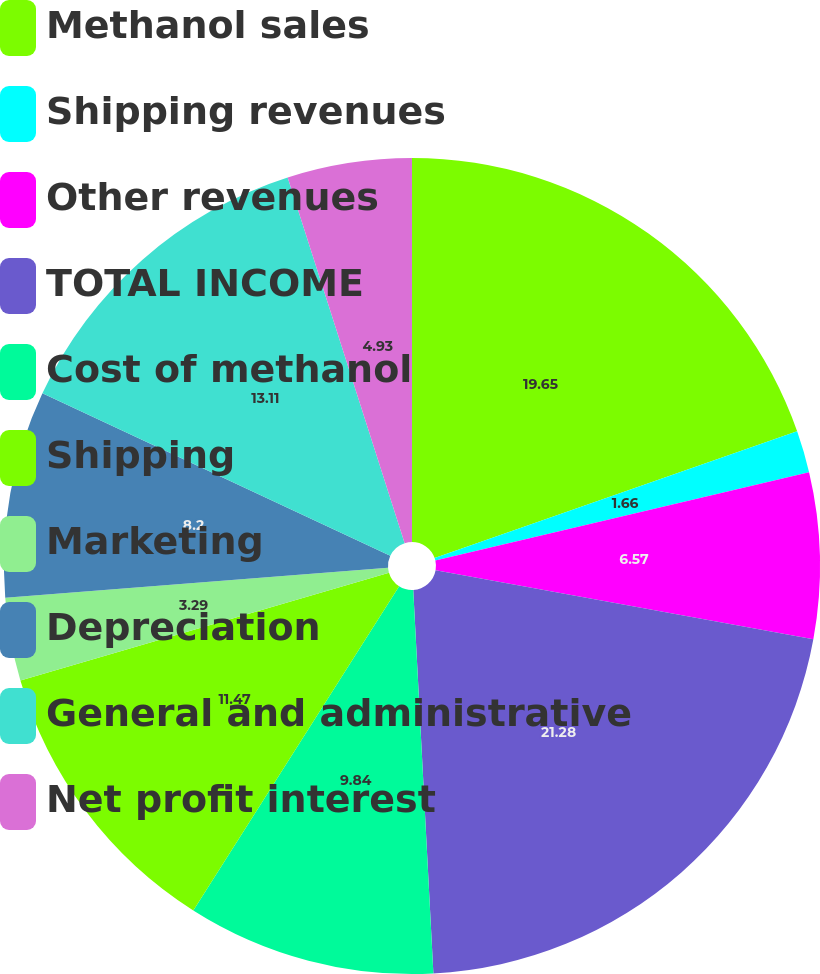<chart> <loc_0><loc_0><loc_500><loc_500><pie_chart><fcel>Methanol sales<fcel>Shipping revenues<fcel>Other revenues<fcel>TOTAL INCOME<fcel>Cost of methanol<fcel>Shipping<fcel>Marketing<fcel>Depreciation<fcel>General and administrative<fcel>Net profit interest<nl><fcel>19.65%<fcel>1.66%<fcel>6.57%<fcel>21.29%<fcel>9.84%<fcel>11.47%<fcel>3.29%<fcel>8.2%<fcel>13.11%<fcel>4.93%<nl></chart> 